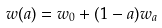Convert formula to latex. <formula><loc_0><loc_0><loc_500><loc_500>w ( a ) = w _ { 0 } + ( 1 - a ) w _ { a }</formula> 